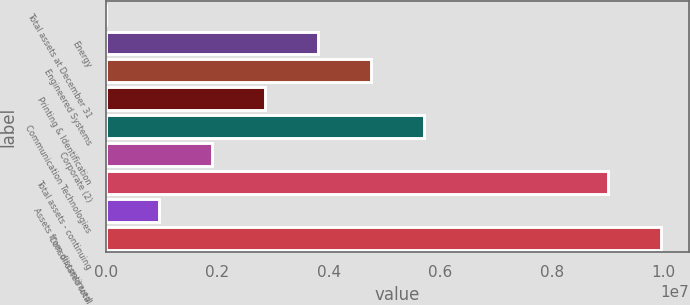<chart> <loc_0><loc_0><loc_500><loc_500><bar_chart><fcel>Total assets at December 31<fcel>Energy<fcel>Engineered Systems<fcel>Printing & Identification<fcel>Communication Technologies<fcel>Corporate (2)<fcel>Total assets - continuing<fcel>Assets from discontinued<fcel>Consolidated total<nl><fcel>2011<fcel>3.80143e+06<fcel>4.75128e+06<fcel>2.85157e+06<fcel>5.70114e+06<fcel>1.90172e+06<fcel>9.01369e+06<fcel>951865<fcel>9.96355e+06<nl></chart> 